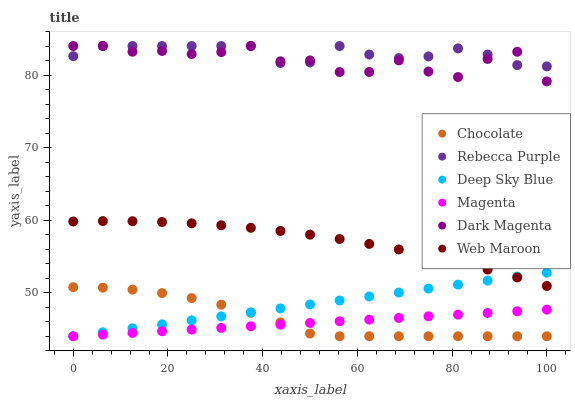Does Magenta have the minimum area under the curve?
Answer yes or no. Yes. Does Rebecca Purple have the maximum area under the curve?
Answer yes or no. Yes. Does Web Maroon have the minimum area under the curve?
Answer yes or no. No. Does Web Maroon have the maximum area under the curve?
Answer yes or no. No. Is Magenta the smoothest?
Answer yes or no. Yes. Is Dark Magenta the roughest?
Answer yes or no. Yes. Is Web Maroon the smoothest?
Answer yes or no. No. Is Web Maroon the roughest?
Answer yes or no. No. Does Chocolate have the lowest value?
Answer yes or no. Yes. Does Web Maroon have the lowest value?
Answer yes or no. No. Does Rebecca Purple have the highest value?
Answer yes or no. Yes. Does Web Maroon have the highest value?
Answer yes or no. No. Is Chocolate less than Dark Magenta?
Answer yes or no. Yes. Is Dark Magenta greater than Web Maroon?
Answer yes or no. Yes. Does Deep Sky Blue intersect Web Maroon?
Answer yes or no. Yes. Is Deep Sky Blue less than Web Maroon?
Answer yes or no. No. Is Deep Sky Blue greater than Web Maroon?
Answer yes or no. No. Does Chocolate intersect Dark Magenta?
Answer yes or no. No. 